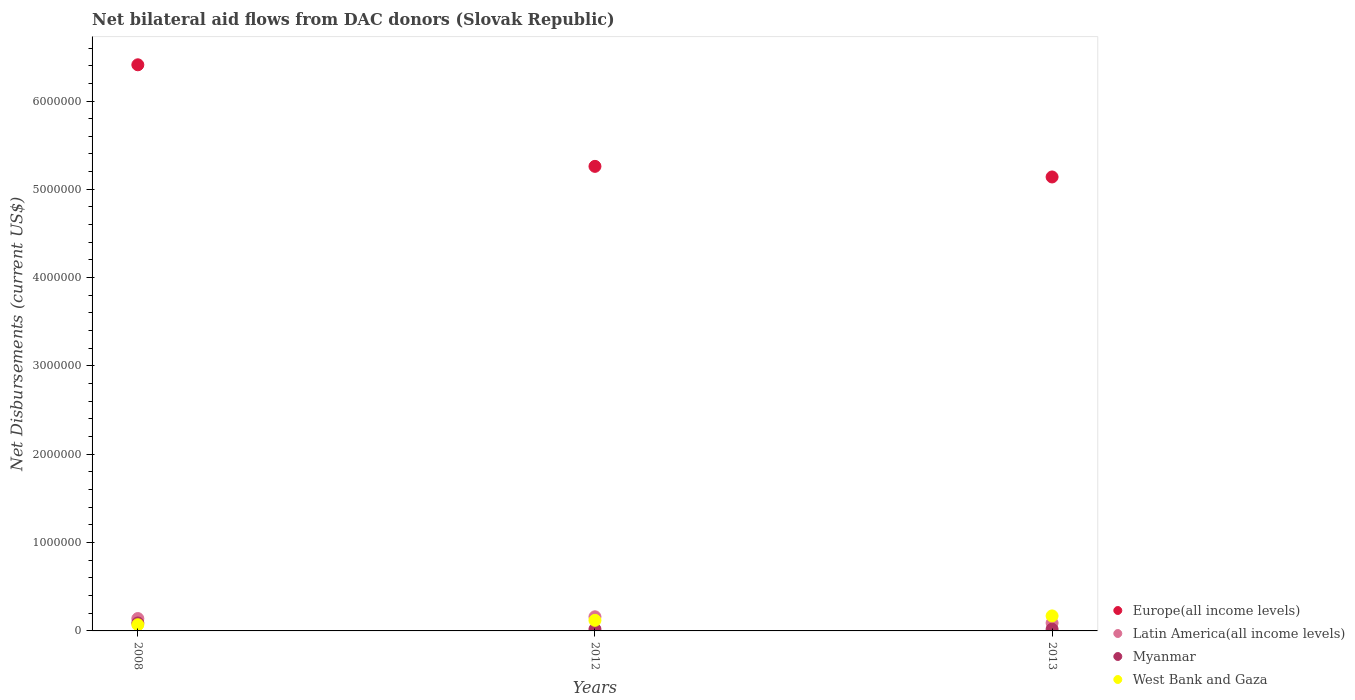Across all years, what is the maximum net bilateral aid flows in Myanmar?
Provide a succinct answer. 9.00e+04. Across all years, what is the minimum net bilateral aid flows in Myanmar?
Keep it short and to the point. 2.00e+04. In which year was the net bilateral aid flows in Latin America(all income levels) minimum?
Give a very brief answer. 2013. What is the total net bilateral aid flows in Europe(all income levels) in the graph?
Your answer should be very brief. 1.68e+07. What is the difference between the net bilateral aid flows in Europe(all income levels) in 2012 and that in 2013?
Your answer should be very brief. 1.20e+05. What is the average net bilateral aid flows in Myanmar per year?
Give a very brief answer. 4.33e+04. In the year 2008, what is the difference between the net bilateral aid flows in Europe(all income levels) and net bilateral aid flows in Myanmar?
Your answer should be very brief. 6.32e+06. In how many years, is the net bilateral aid flows in Europe(all income levels) greater than 5600000 US$?
Provide a short and direct response. 1. What is the ratio of the net bilateral aid flows in Europe(all income levels) in 2008 to that in 2013?
Make the answer very short. 1.25. Is the difference between the net bilateral aid flows in Europe(all income levels) in 2008 and 2013 greater than the difference between the net bilateral aid flows in Myanmar in 2008 and 2013?
Your answer should be very brief. Yes. What is the difference between the highest and the second highest net bilateral aid flows in Europe(all income levels)?
Your answer should be very brief. 1.15e+06. What is the difference between the highest and the lowest net bilateral aid flows in Myanmar?
Offer a very short reply. 7.00e+04. Is the sum of the net bilateral aid flows in West Bank and Gaza in 2008 and 2013 greater than the maximum net bilateral aid flows in Myanmar across all years?
Offer a very short reply. Yes. Is the net bilateral aid flows in West Bank and Gaza strictly greater than the net bilateral aid flows in Latin America(all income levels) over the years?
Give a very brief answer. No. How many years are there in the graph?
Keep it short and to the point. 3. Are the values on the major ticks of Y-axis written in scientific E-notation?
Make the answer very short. No. Where does the legend appear in the graph?
Offer a very short reply. Bottom right. How many legend labels are there?
Your answer should be compact. 4. What is the title of the graph?
Provide a succinct answer. Net bilateral aid flows from DAC donors (Slovak Republic). What is the label or title of the Y-axis?
Your answer should be compact. Net Disbursements (current US$). What is the Net Disbursements (current US$) in Europe(all income levels) in 2008?
Provide a short and direct response. 6.41e+06. What is the Net Disbursements (current US$) of Myanmar in 2008?
Provide a succinct answer. 9.00e+04. What is the Net Disbursements (current US$) of Europe(all income levels) in 2012?
Offer a terse response. 5.26e+06. What is the Net Disbursements (current US$) of Myanmar in 2012?
Offer a very short reply. 2.00e+04. What is the Net Disbursements (current US$) of Europe(all income levels) in 2013?
Your answer should be compact. 5.14e+06. What is the Net Disbursements (current US$) of Latin America(all income levels) in 2013?
Make the answer very short. 9.00e+04. What is the Net Disbursements (current US$) in Myanmar in 2013?
Provide a succinct answer. 2.00e+04. What is the Net Disbursements (current US$) in West Bank and Gaza in 2013?
Offer a very short reply. 1.70e+05. Across all years, what is the maximum Net Disbursements (current US$) of Europe(all income levels)?
Keep it short and to the point. 6.41e+06. Across all years, what is the maximum Net Disbursements (current US$) of Latin America(all income levels)?
Your answer should be very brief. 1.60e+05. Across all years, what is the maximum Net Disbursements (current US$) of West Bank and Gaza?
Provide a short and direct response. 1.70e+05. Across all years, what is the minimum Net Disbursements (current US$) of Europe(all income levels)?
Your answer should be compact. 5.14e+06. Across all years, what is the minimum Net Disbursements (current US$) of Myanmar?
Provide a short and direct response. 2.00e+04. What is the total Net Disbursements (current US$) of Europe(all income levels) in the graph?
Your answer should be very brief. 1.68e+07. What is the total Net Disbursements (current US$) in West Bank and Gaza in the graph?
Provide a succinct answer. 3.60e+05. What is the difference between the Net Disbursements (current US$) of Europe(all income levels) in 2008 and that in 2012?
Offer a terse response. 1.15e+06. What is the difference between the Net Disbursements (current US$) in Latin America(all income levels) in 2008 and that in 2012?
Your answer should be compact. -2.00e+04. What is the difference between the Net Disbursements (current US$) of Europe(all income levels) in 2008 and that in 2013?
Your response must be concise. 1.27e+06. What is the difference between the Net Disbursements (current US$) of Latin America(all income levels) in 2008 and that in 2013?
Offer a terse response. 5.00e+04. What is the difference between the Net Disbursements (current US$) of Myanmar in 2008 and that in 2013?
Give a very brief answer. 7.00e+04. What is the difference between the Net Disbursements (current US$) in West Bank and Gaza in 2012 and that in 2013?
Keep it short and to the point. -5.00e+04. What is the difference between the Net Disbursements (current US$) of Europe(all income levels) in 2008 and the Net Disbursements (current US$) of Latin America(all income levels) in 2012?
Your response must be concise. 6.25e+06. What is the difference between the Net Disbursements (current US$) of Europe(all income levels) in 2008 and the Net Disbursements (current US$) of Myanmar in 2012?
Provide a short and direct response. 6.39e+06. What is the difference between the Net Disbursements (current US$) of Europe(all income levels) in 2008 and the Net Disbursements (current US$) of West Bank and Gaza in 2012?
Your answer should be very brief. 6.29e+06. What is the difference between the Net Disbursements (current US$) of Latin America(all income levels) in 2008 and the Net Disbursements (current US$) of Myanmar in 2012?
Your answer should be compact. 1.20e+05. What is the difference between the Net Disbursements (current US$) of Latin America(all income levels) in 2008 and the Net Disbursements (current US$) of West Bank and Gaza in 2012?
Your answer should be very brief. 2.00e+04. What is the difference between the Net Disbursements (current US$) of Europe(all income levels) in 2008 and the Net Disbursements (current US$) of Latin America(all income levels) in 2013?
Make the answer very short. 6.32e+06. What is the difference between the Net Disbursements (current US$) in Europe(all income levels) in 2008 and the Net Disbursements (current US$) in Myanmar in 2013?
Your response must be concise. 6.39e+06. What is the difference between the Net Disbursements (current US$) of Europe(all income levels) in 2008 and the Net Disbursements (current US$) of West Bank and Gaza in 2013?
Provide a succinct answer. 6.24e+06. What is the difference between the Net Disbursements (current US$) in Latin America(all income levels) in 2008 and the Net Disbursements (current US$) in Myanmar in 2013?
Make the answer very short. 1.20e+05. What is the difference between the Net Disbursements (current US$) in Myanmar in 2008 and the Net Disbursements (current US$) in West Bank and Gaza in 2013?
Your response must be concise. -8.00e+04. What is the difference between the Net Disbursements (current US$) of Europe(all income levels) in 2012 and the Net Disbursements (current US$) of Latin America(all income levels) in 2013?
Provide a succinct answer. 5.17e+06. What is the difference between the Net Disbursements (current US$) in Europe(all income levels) in 2012 and the Net Disbursements (current US$) in Myanmar in 2013?
Your answer should be very brief. 5.24e+06. What is the difference between the Net Disbursements (current US$) of Europe(all income levels) in 2012 and the Net Disbursements (current US$) of West Bank and Gaza in 2013?
Provide a short and direct response. 5.09e+06. What is the difference between the Net Disbursements (current US$) of Latin America(all income levels) in 2012 and the Net Disbursements (current US$) of Myanmar in 2013?
Your response must be concise. 1.40e+05. What is the average Net Disbursements (current US$) of Europe(all income levels) per year?
Your response must be concise. 5.60e+06. What is the average Net Disbursements (current US$) of Latin America(all income levels) per year?
Your answer should be very brief. 1.30e+05. What is the average Net Disbursements (current US$) in Myanmar per year?
Provide a succinct answer. 4.33e+04. In the year 2008, what is the difference between the Net Disbursements (current US$) in Europe(all income levels) and Net Disbursements (current US$) in Latin America(all income levels)?
Your answer should be compact. 6.27e+06. In the year 2008, what is the difference between the Net Disbursements (current US$) in Europe(all income levels) and Net Disbursements (current US$) in Myanmar?
Your answer should be compact. 6.32e+06. In the year 2008, what is the difference between the Net Disbursements (current US$) in Europe(all income levels) and Net Disbursements (current US$) in West Bank and Gaza?
Provide a short and direct response. 6.34e+06. In the year 2008, what is the difference between the Net Disbursements (current US$) of Latin America(all income levels) and Net Disbursements (current US$) of Myanmar?
Offer a very short reply. 5.00e+04. In the year 2008, what is the difference between the Net Disbursements (current US$) in Latin America(all income levels) and Net Disbursements (current US$) in West Bank and Gaza?
Ensure brevity in your answer.  7.00e+04. In the year 2012, what is the difference between the Net Disbursements (current US$) in Europe(all income levels) and Net Disbursements (current US$) in Latin America(all income levels)?
Your answer should be compact. 5.10e+06. In the year 2012, what is the difference between the Net Disbursements (current US$) of Europe(all income levels) and Net Disbursements (current US$) of Myanmar?
Your response must be concise. 5.24e+06. In the year 2012, what is the difference between the Net Disbursements (current US$) of Europe(all income levels) and Net Disbursements (current US$) of West Bank and Gaza?
Your answer should be compact. 5.14e+06. In the year 2012, what is the difference between the Net Disbursements (current US$) in Myanmar and Net Disbursements (current US$) in West Bank and Gaza?
Ensure brevity in your answer.  -1.00e+05. In the year 2013, what is the difference between the Net Disbursements (current US$) in Europe(all income levels) and Net Disbursements (current US$) in Latin America(all income levels)?
Provide a succinct answer. 5.05e+06. In the year 2013, what is the difference between the Net Disbursements (current US$) of Europe(all income levels) and Net Disbursements (current US$) of Myanmar?
Give a very brief answer. 5.12e+06. In the year 2013, what is the difference between the Net Disbursements (current US$) of Europe(all income levels) and Net Disbursements (current US$) of West Bank and Gaza?
Your answer should be very brief. 4.97e+06. What is the ratio of the Net Disbursements (current US$) of Europe(all income levels) in 2008 to that in 2012?
Your answer should be compact. 1.22. What is the ratio of the Net Disbursements (current US$) in Latin America(all income levels) in 2008 to that in 2012?
Your answer should be very brief. 0.88. What is the ratio of the Net Disbursements (current US$) in West Bank and Gaza in 2008 to that in 2012?
Your answer should be very brief. 0.58. What is the ratio of the Net Disbursements (current US$) of Europe(all income levels) in 2008 to that in 2013?
Offer a very short reply. 1.25. What is the ratio of the Net Disbursements (current US$) of Latin America(all income levels) in 2008 to that in 2013?
Ensure brevity in your answer.  1.56. What is the ratio of the Net Disbursements (current US$) in Myanmar in 2008 to that in 2013?
Your answer should be very brief. 4.5. What is the ratio of the Net Disbursements (current US$) of West Bank and Gaza in 2008 to that in 2013?
Give a very brief answer. 0.41. What is the ratio of the Net Disbursements (current US$) in Europe(all income levels) in 2012 to that in 2013?
Provide a succinct answer. 1.02. What is the ratio of the Net Disbursements (current US$) in Latin America(all income levels) in 2012 to that in 2013?
Your answer should be very brief. 1.78. What is the ratio of the Net Disbursements (current US$) of West Bank and Gaza in 2012 to that in 2013?
Give a very brief answer. 0.71. What is the difference between the highest and the second highest Net Disbursements (current US$) in Europe(all income levels)?
Your answer should be very brief. 1.15e+06. What is the difference between the highest and the second highest Net Disbursements (current US$) in Latin America(all income levels)?
Your answer should be very brief. 2.00e+04. What is the difference between the highest and the lowest Net Disbursements (current US$) of Europe(all income levels)?
Keep it short and to the point. 1.27e+06. What is the difference between the highest and the lowest Net Disbursements (current US$) in Latin America(all income levels)?
Make the answer very short. 7.00e+04. What is the difference between the highest and the lowest Net Disbursements (current US$) of Myanmar?
Your answer should be compact. 7.00e+04. 